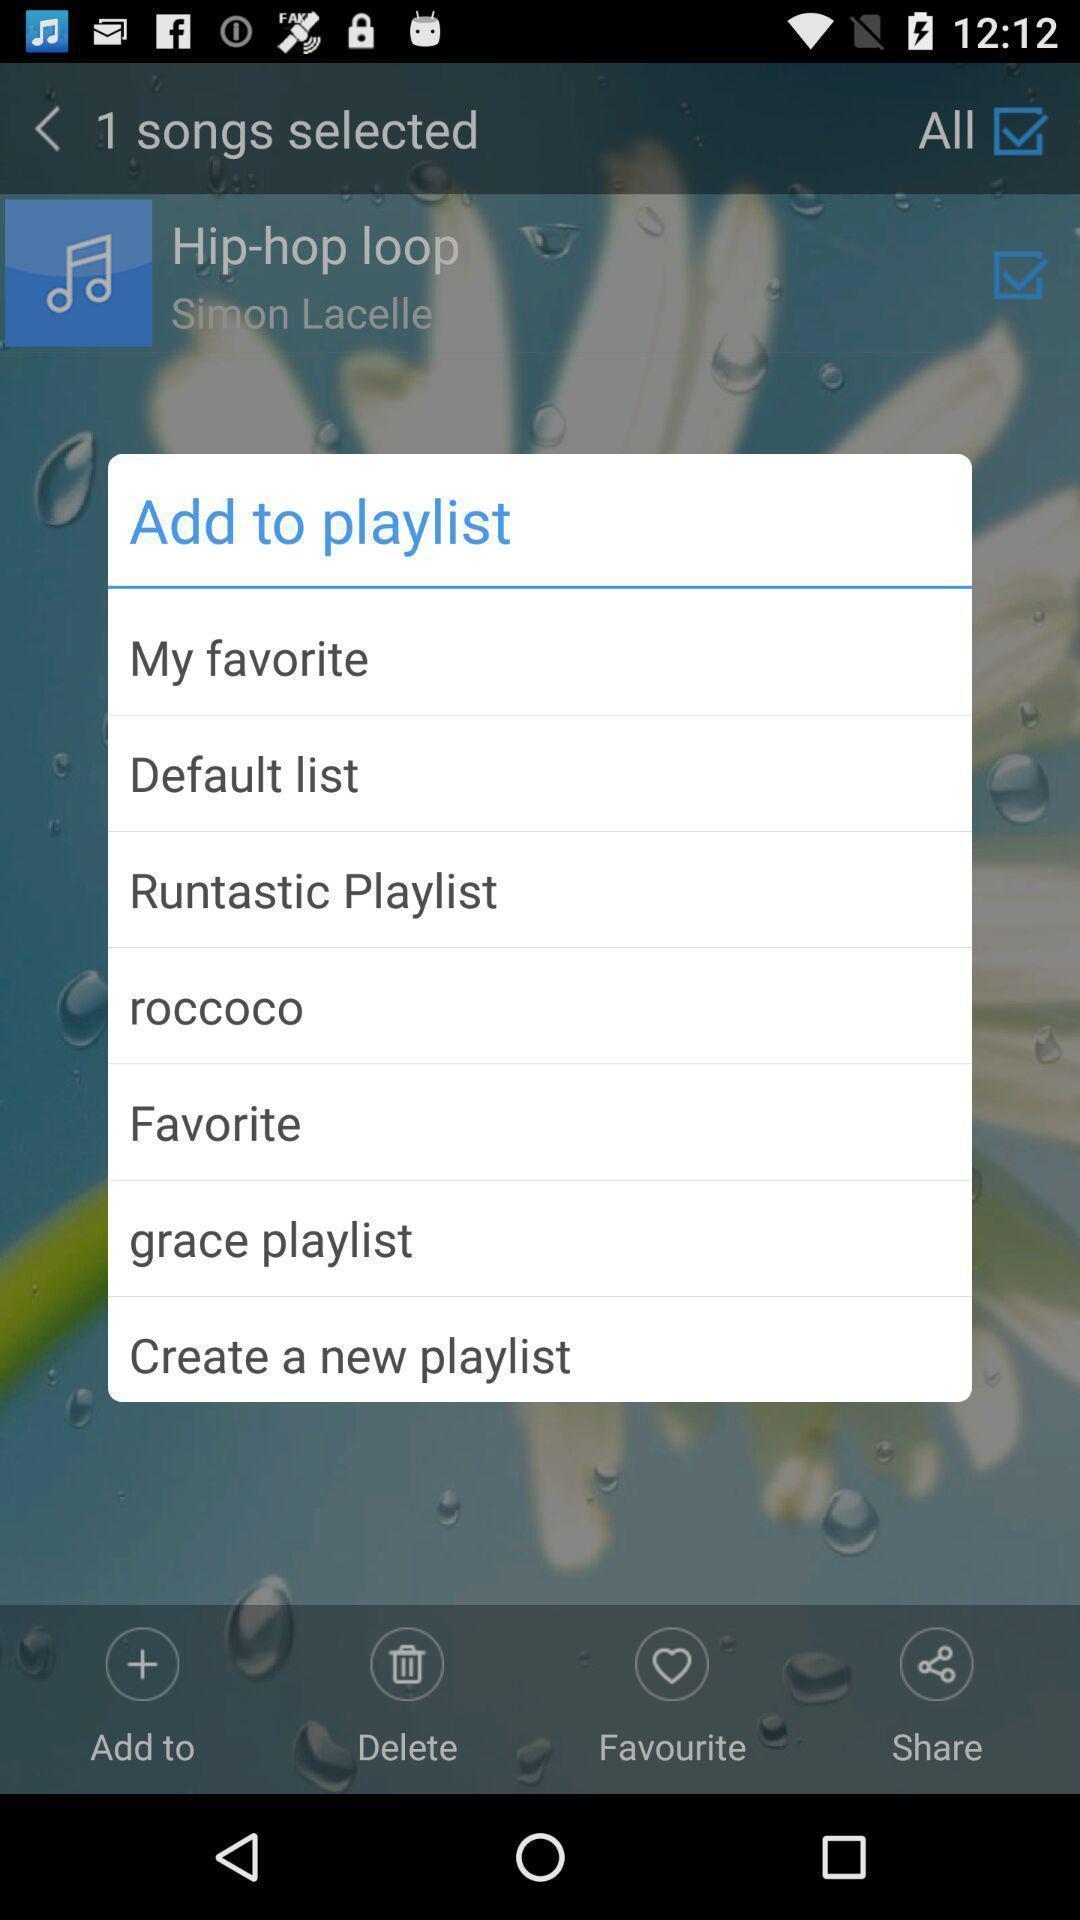Summarize the main components in this picture. Pop-up showing various options to add a playlist. 